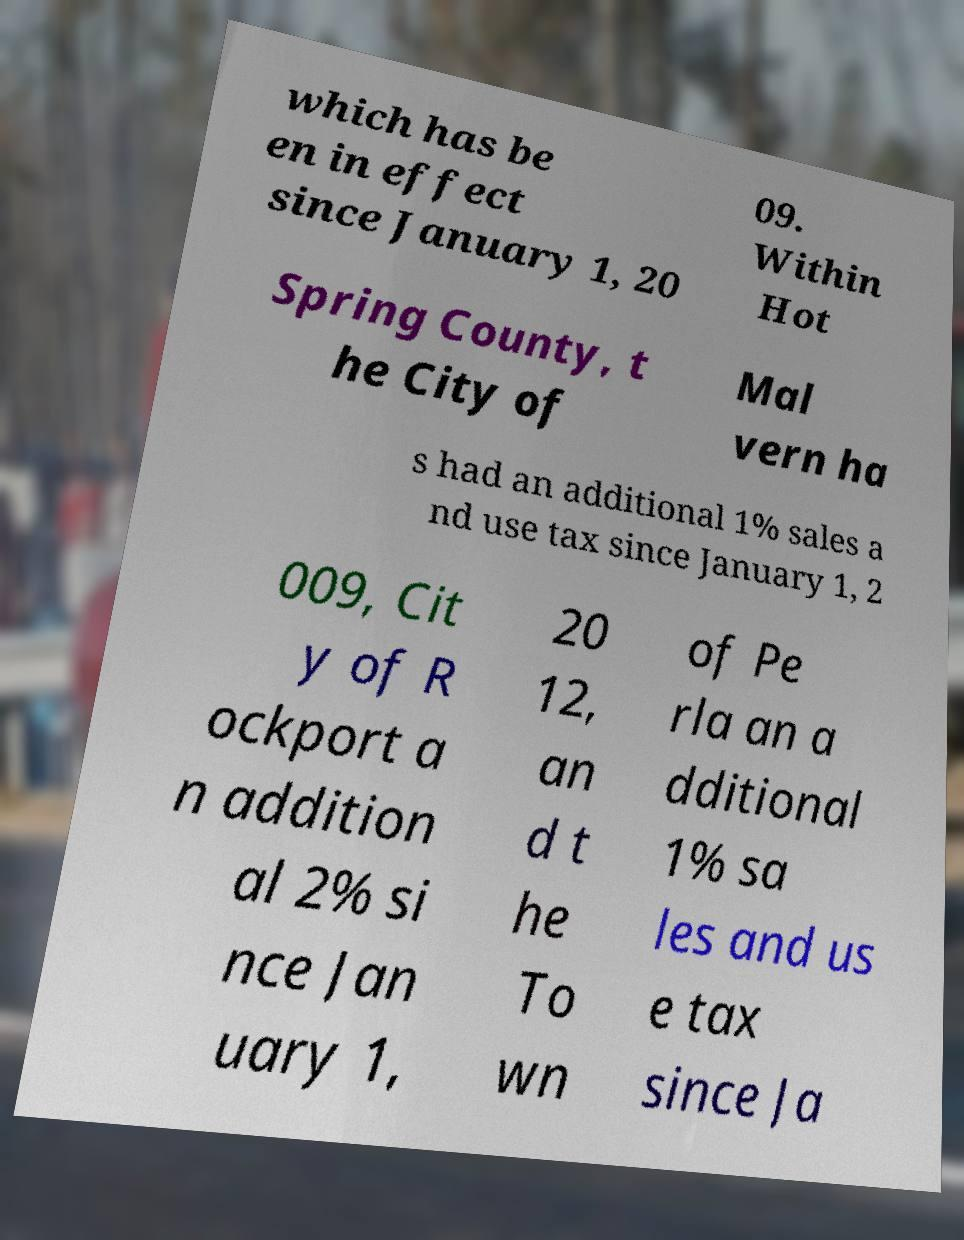Could you extract and type out the text from this image? which has be en in effect since January 1, 20 09. Within Hot Spring County, t he City of Mal vern ha s had an additional 1% sales a nd use tax since January 1, 2 009, Cit y of R ockport a n addition al 2% si nce Jan uary 1, 20 12, an d t he To wn of Pe rla an a dditional 1% sa les and us e tax since Ja 